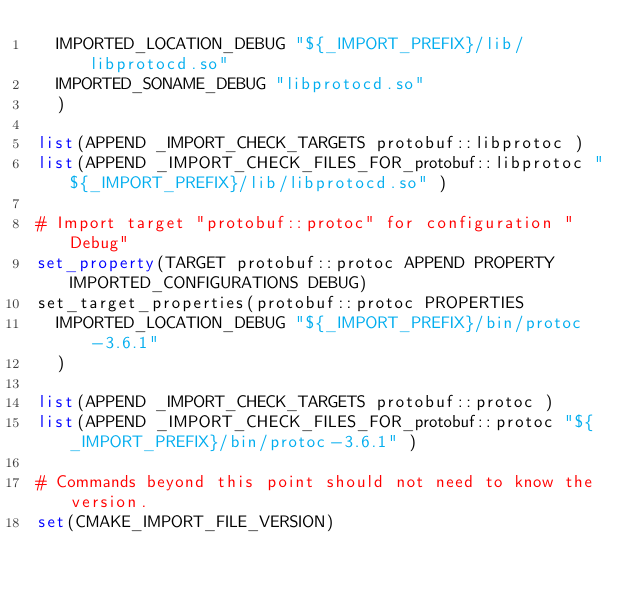Convert code to text. <code><loc_0><loc_0><loc_500><loc_500><_CMake_>  IMPORTED_LOCATION_DEBUG "${_IMPORT_PREFIX}/lib/libprotocd.so"
  IMPORTED_SONAME_DEBUG "libprotocd.so"
  )

list(APPEND _IMPORT_CHECK_TARGETS protobuf::libprotoc )
list(APPEND _IMPORT_CHECK_FILES_FOR_protobuf::libprotoc "${_IMPORT_PREFIX}/lib/libprotocd.so" )

# Import target "protobuf::protoc" for configuration "Debug"
set_property(TARGET protobuf::protoc APPEND PROPERTY IMPORTED_CONFIGURATIONS DEBUG)
set_target_properties(protobuf::protoc PROPERTIES
  IMPORTED_LOCATION_DEBUG "${_IMPORT_PREFIX}/bin/protoc-3.6.1"
  )

list(APPEND _IMPORT_CHECK_TARGETS protobuf::protoc )
list(APPEND _IMPORT_CHECK_FILES_FOR_protobuf::protoc "${_IMPORT_PREFIX}/bin/protoc-3.6.1" )

# Commands beyond this point should not need to know the version.
set(CMAKE_IMPORT_FILE_VERSION)
</code> 